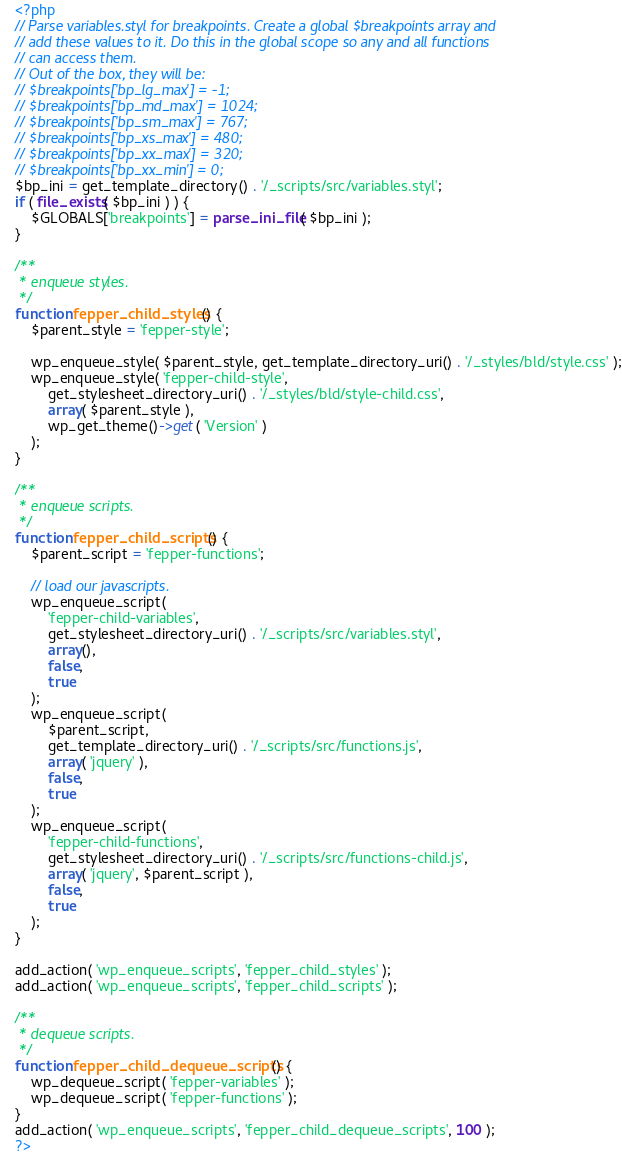Convert code to text. <code><loc_0><loc_0><loc_500><loc_500><_PHP_><?php
// Parse variables.styl for breakpoints. Create a global $breakpoints array and
// add these values to it. Do this in the global scope so any and all functions
// can access them.
// Out of the box, they will be:
// $breakpoints['bp_lg_max'] = -1;
// $breakpoints['bp_md_max'] = 1024;
// $breakpoints['bp_sm_max'] = 767;
// $breakpoints['bp_xs_max'] = 480;
// $breakpoints['bp_xx_max'] = 320;
// $breakpoints['bp_xx_min'] = 0;
$bp_ini = get_template_directory() . '/_scripts/src/variables.styl';
if ( file_exists( $bp_ini ) ) {
	$GLOBALS['breakpoints'] = parse_ini_file( $bp_ini );
}

/**
 * enqueue styles.
 */
function fepper_child_styles() {
	$parent_style = 'fepper-style';

	wp_enqueue_style( $parent_style, get_template_directory_uri() . '/_styles/bld/style.css' );
	wp_enqueue_style( 'fepper-child-style',
		get_stylesheet_directory_uri() . '/_styles/bld/style-child.css',
		array( $parent_style ),
		wp_get_theme()->get( 'Version' )
	);
}

/**
 * enqueue scripts.
 */
function fepper_child_scripts() {
	$parent_script = 'fepper-functions';

	// load our javascripts.
	wp_enqueue_script(
		'fepper-child-variables',
		get_stylesheet_directory_uri() . '/_scripts/src/variables.styl',
		array(),
		false,
		true
	);
	wp_enqueue_script(
		$parent_script,
		get_template_directory_uri() . '/_scripts/src/functions.js',
		array( 'jquery' ),
		false,
		true
	);
	wp_enqueue_script(
		'fepper-child-functions',
		get_stylesheet_directory_uri() . '/_scripts/src/functions-child.js',
		array( 'jquery', $parent_script ),
		false,
		true
	);
}

add_action( 'wp_enqueue_scripts', 'fepper_child_styles' );
add_action( 'wp_enqueue_scripts', 'fepper_child_scripts' );

/**
 * dequeue scripts.
 */
function fepper_child_dequeue_scripts() {
	wp_dequeue_script( 'fepper-variables' );
	wp_dequeue_script( 'fepper-functions' );
}
add_action( 'wp_enqueue_scripts', 'fepper_child_dequeue_scripts', 100 );
?>
</code> 